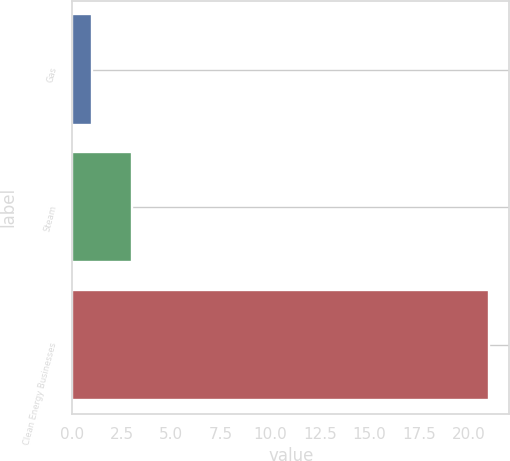<chart> <loc_0><loc_0><loc_500><loc_500><bar_chart><fcel>Gas<fcel>Steam<fcel>Clean Energy Businesses<nl><fcel>1<fcel>3<fcel>21<nl></chart> 